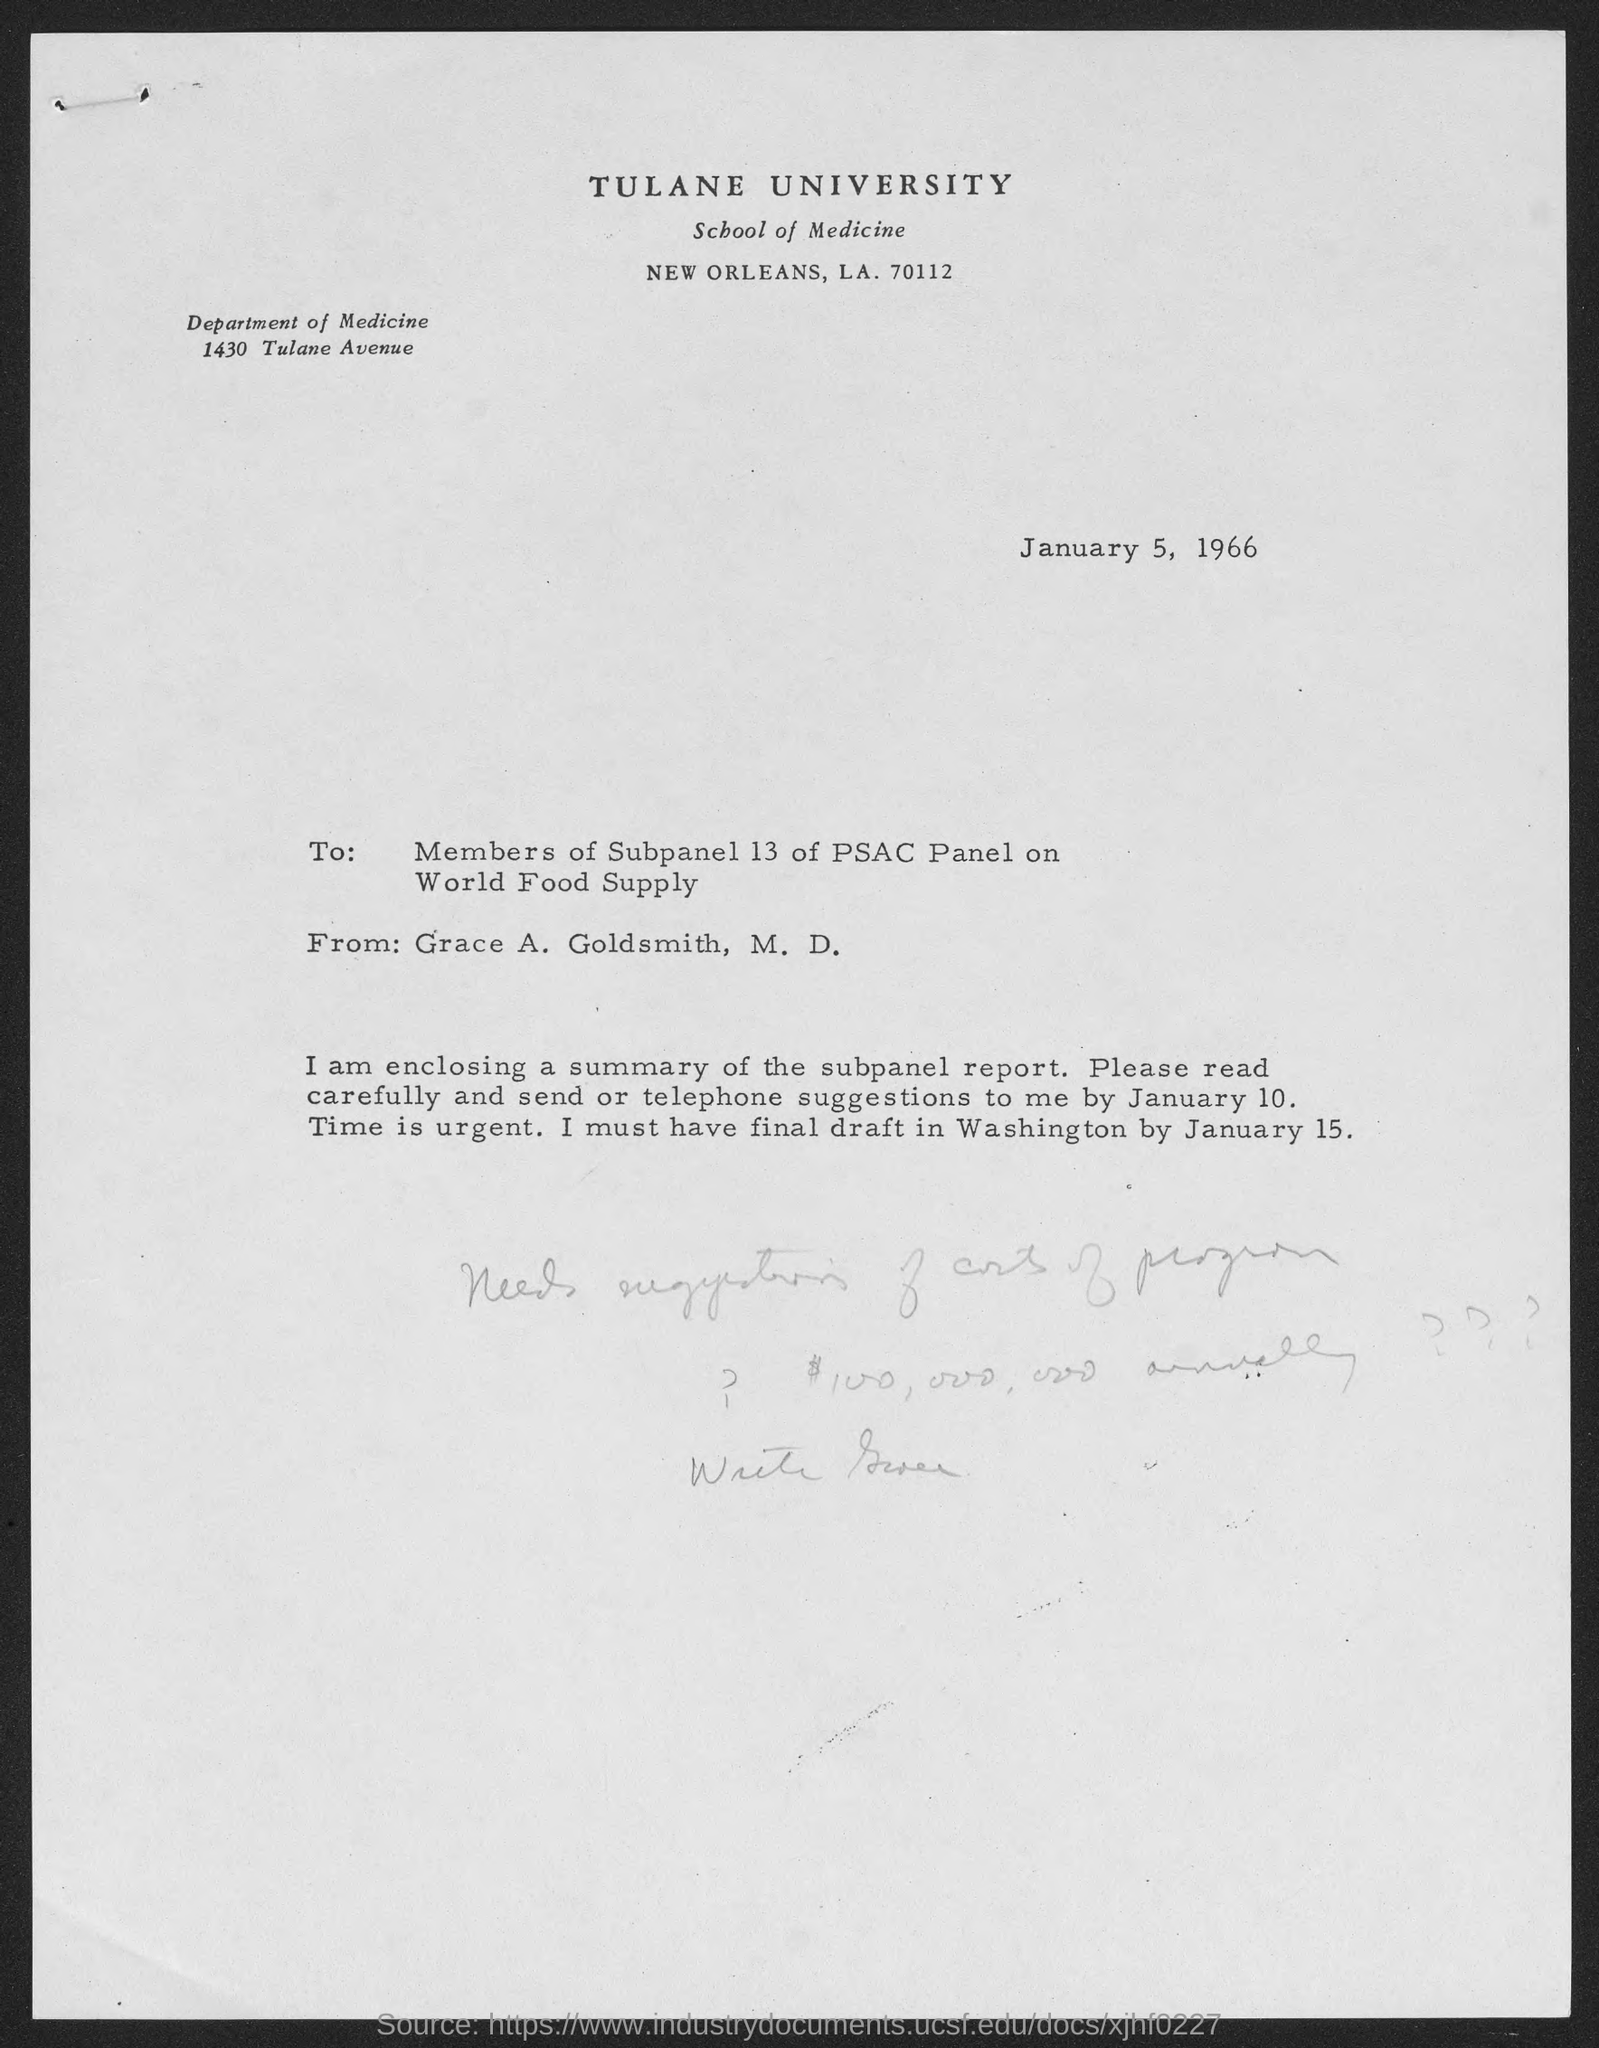In which county is tulane university at?
Your response must be concise. New Orleans. What is the avenue address of department of medicine ?
Your answer should be compact. 1430 Tulane Avenue. When is the memorandum dated?
Your answer should be very brief. January 5 , 1966. 